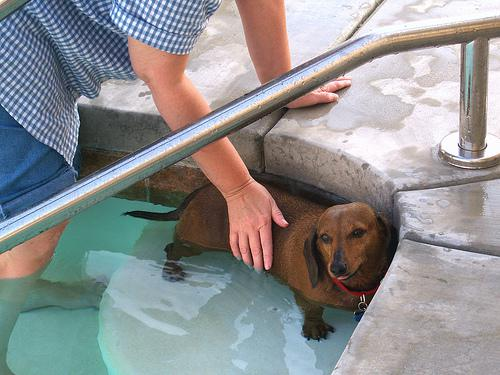Question: why is the woman holding the dog?
Choices:
A. To keep it in the pool.
B. To snuggle it.
C. To clean it.
D. To love it.
Answer with the letter. Answer: A Question: who is holding the dog?
Choices:
A. A man.
B. A boy.
C. A woman.
D. A girl.
Answer with the letter. Answer: C Question: what color shirt is the woman wearing?
Choices:
A. Blue and white.
B. Red and blue.
C. Green and white.
D. Yellow and black.
Answer with the letter. Answer: A Question: what is he standing on?
Choices:
A. A deck.
B. A patio.
C. A rug.
D. A step.
Answer with the letter. Answer: D 